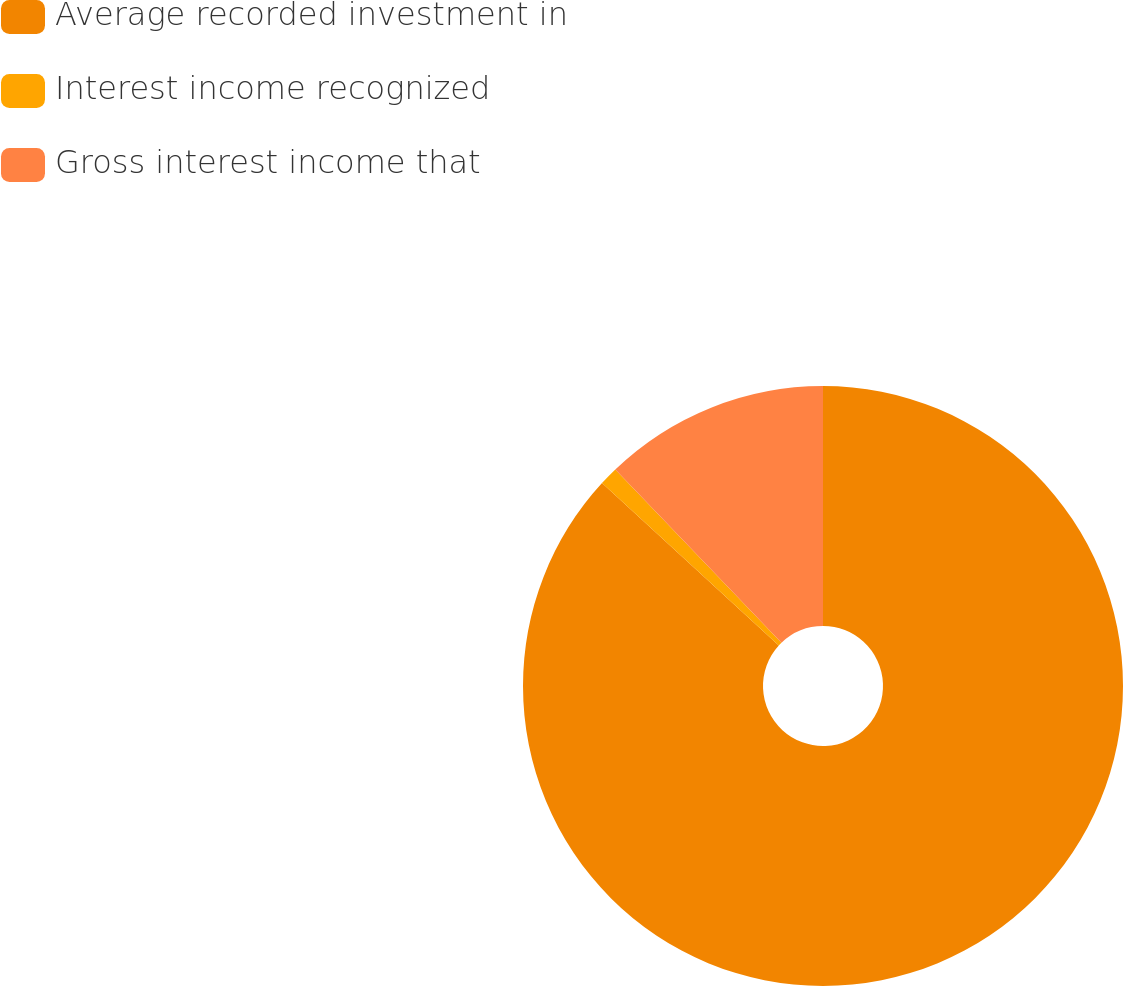<chart> <loc_0><loc_0><loc_500><loc_500><pie_chart><fcel>Average recorded investment in<fcel>Interest income recognized<fcel>Gross interest income that<nl><fcel>86.82%<fcel>1.01%<fcel>12.17%<nl></chart> 